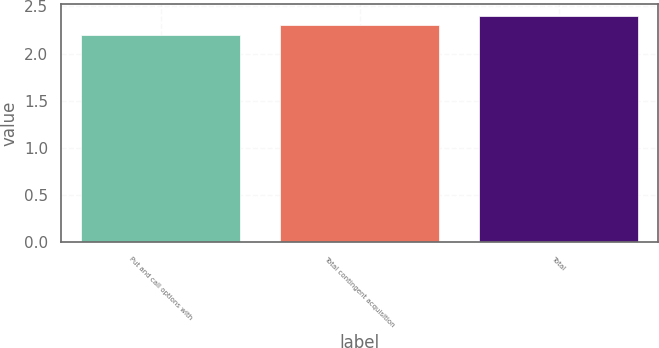Convert chart. <chart><loc_0><loc_0><loc_500><loc_500><bar_chart><fcel>Put and call options with<fcel>Total contingent acquisition<fcel>Total<nl><fcel>2.2<fcel>2.3<fcel>2.4<nl></chart> 